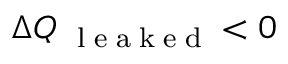Convert formula to latex. <formula><loc_0><loc_0><loc_500><loc_500>\Delta Q _ { l e a k e d } < 0</formula> 